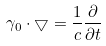<formula> <loc_0><loc_0><loc_500><loc_500>\gamma _ { 0 } \cdot \bigtriangledown = { \frac { 1 } { c } } { \frac { \partial } { \partial t } }</formula> 